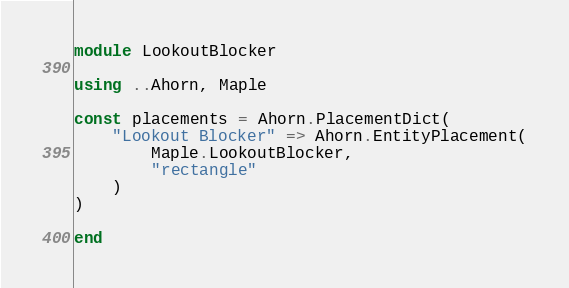<code> <loc_0><loc_0><loc_500><loc_500><_Julia_>module LookoutBlocker

using ..Ahorn, Maple

const placements = Ahorn.PlacementDict(
    "Lookout Blocker" => Ahorn.EntityPlacement(
        Maple.LookoutBlocker,
        "rectangle"
    )
)

end</code> 